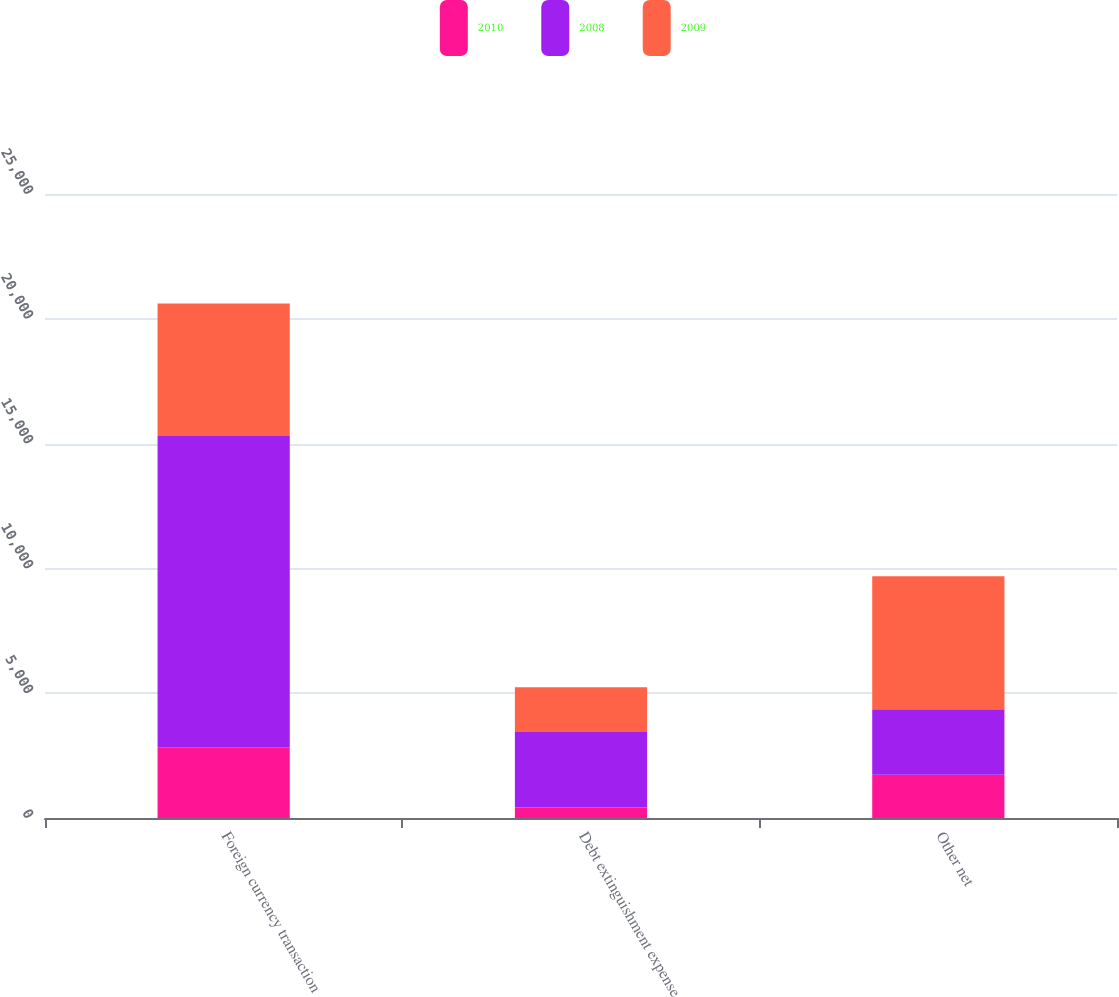<chart> <loc_0><loc_0><loc_500><loc_500><stacked_bar_chart><ecel><fcel>Foreign currency transaction<fcel>Debt extinguishment expense<fcel>Other net<nl><fcel>2010<fcel>2832<fcel>418<fcel>1728<nl><fcel>2008<fcel>12477<fcel>3031<fcel>2633<nl><fcel>2009<fcel>5305<fcel>1792<fcel>5325<nl></chart> 